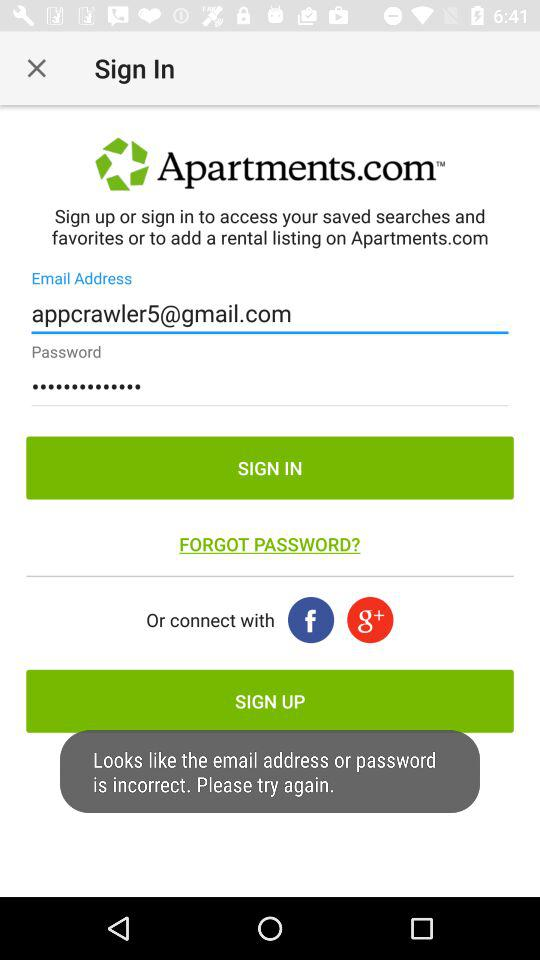Which accounts can I use to sign in? You can use "Email Address", "Facebook" and "Google+" to sign in. 